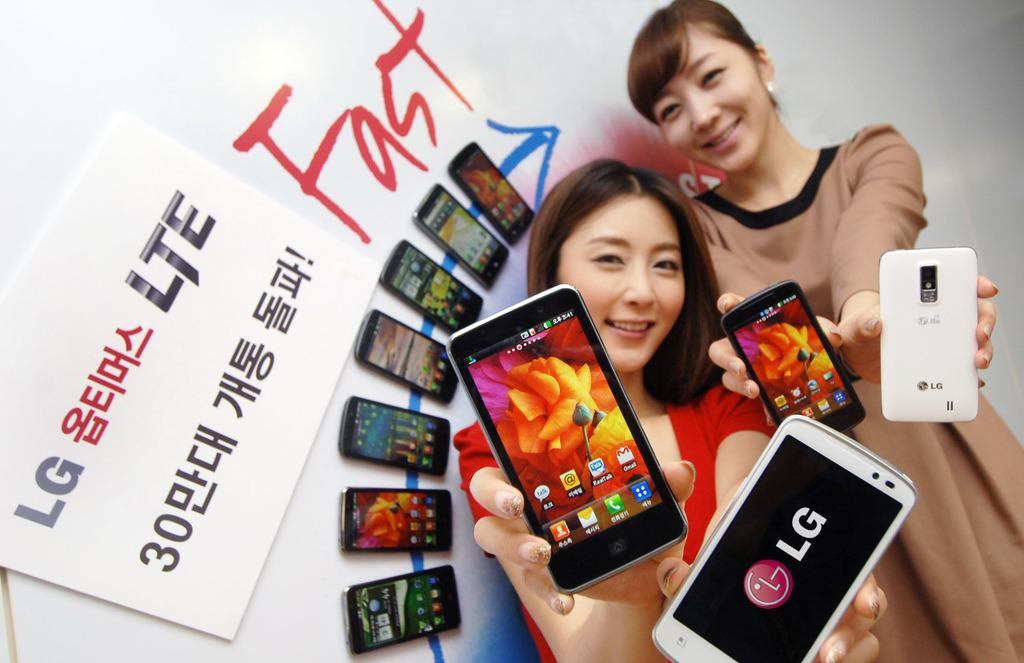<image>
Render a clear and concise summary of the photo. Two women are each holding LG phones in goth of their hands and smiling, with a display of phones by them. 